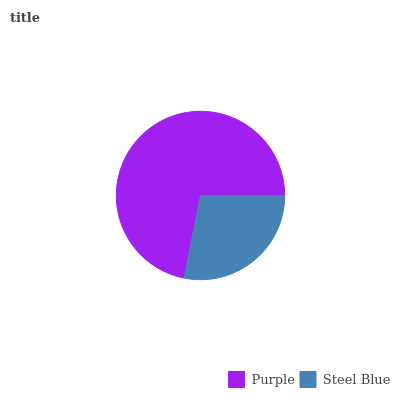Is Steel Blue the minimum?
Answer yes or no. Yes. Is Purple the maximum?
Answer yes or no. Yes. Is Steel Blue the maximum?
Answer yes or no. No. Is Purple greater than Steel Blue?
Answer yes or no. Yes. Is Steel Blue less than Purple?
Answer yes or no. Yes. Is Steel Blue greater than Purple?
Answer yes or no. No. Is Purple less than Steel Blue?
Answer yes or no. No. Is Purple the high median?
Answer yes or no. Yes. Is Steel Blue the low median?
Answer yes or no. Yes. Is Steel Blue the high median?
Answer yes or no. No. Is Purple the low median?
Answer yes or no. No. 